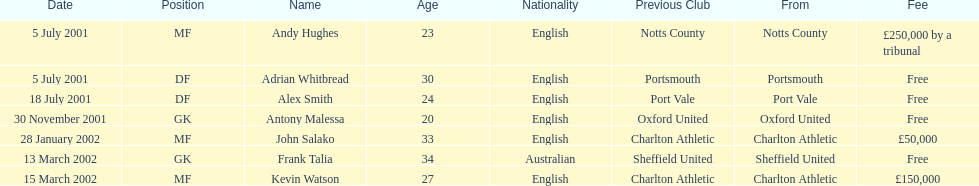Which transfer in was next after john salako's in 2002? Frank Talia. 